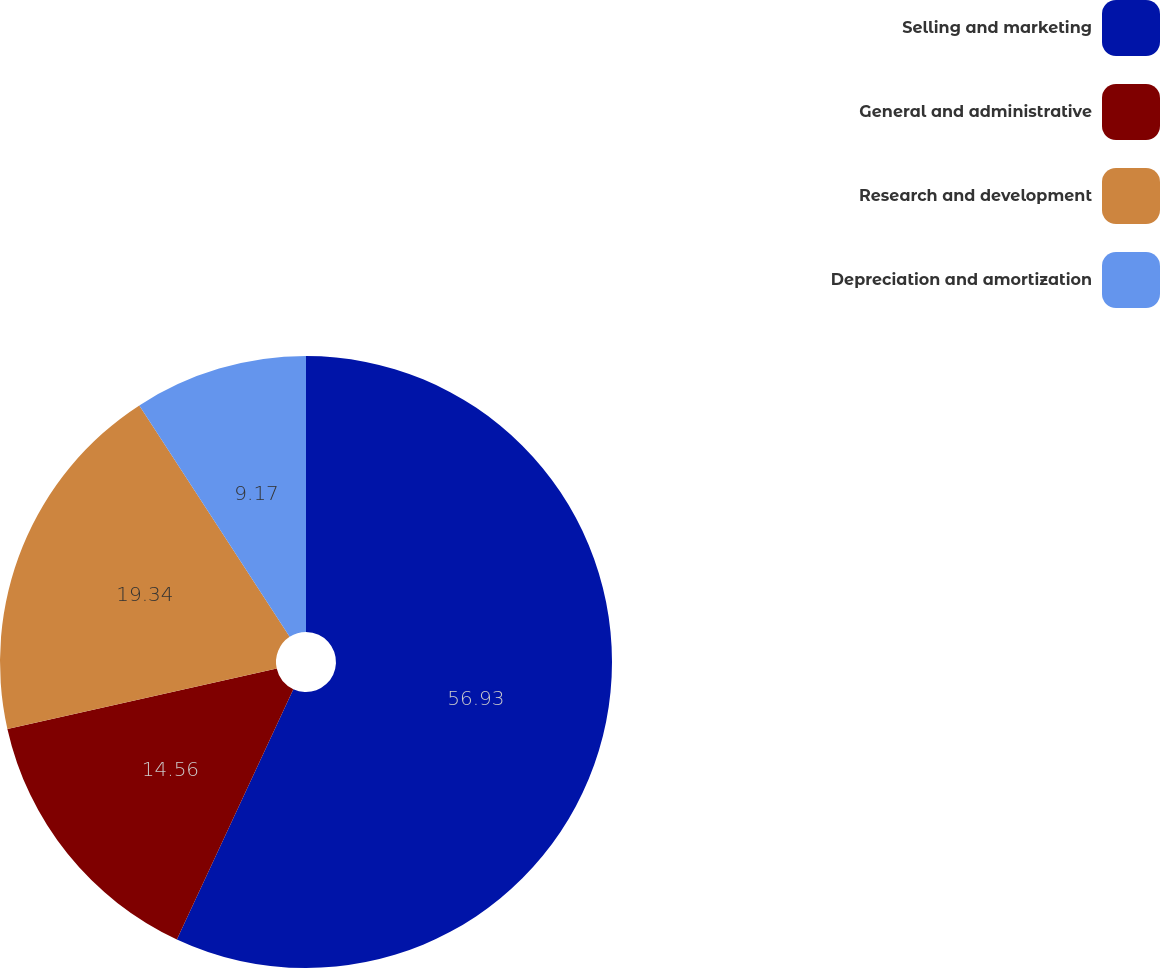<chart> <loc_0><loc_0><loc_500><loc_500><pie_chart><fcel>Selling and marketing<fcel>General and administrative<fcel>Research and development<fcel>Depreciation and amortization<nl><fcel>56.94%<fcel>14.56%<fcel>19.34%<fcel>9.17%<nl></chart> 